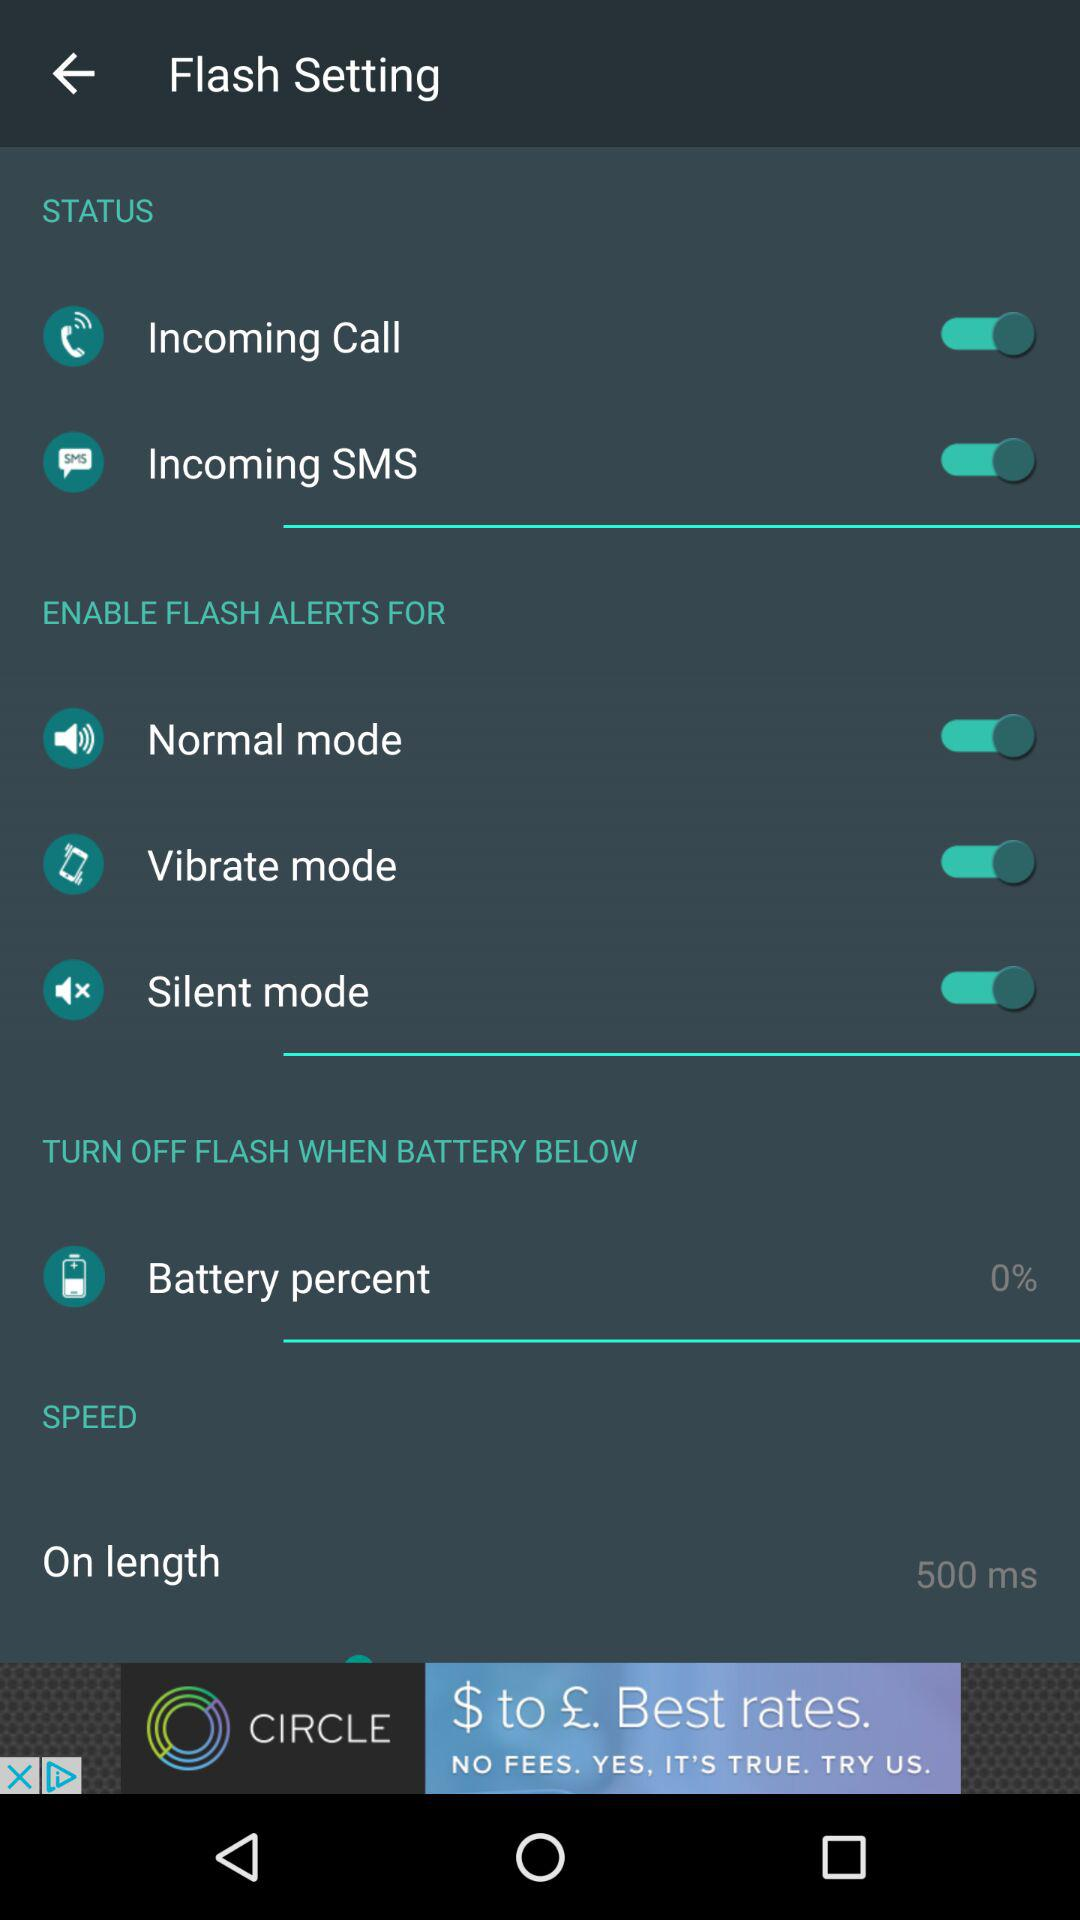How long is the on length for the flash?
Answer the question using a single word or phrase. 500 ms 